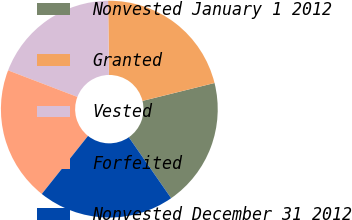Convert chart to OTSL. <chart><loc_0><loc_0><loc_500><loc_500><pie_chart><fcel>Nonvested January 1 2012<fcel>Granted<fcel>Vested<fcel>Forfeited<fcel>Nonvested December 31 2012<nl><fcel>19.22%<fcel>21.3%<fcel>19.0%<fcel>20.12%<fcel>20.36%<nl></chart> 